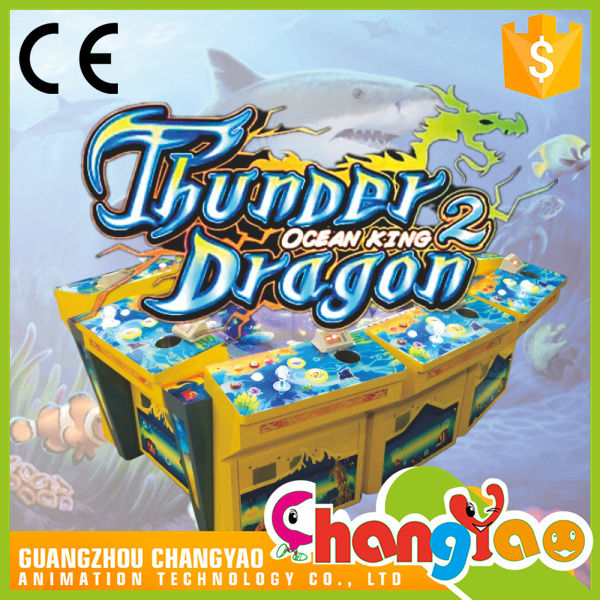What type of game does "Thunder Dragon 2 Ocean King" imply, based on the imagery and controls visible? Based on the imagery and controls visible on the arcade machine, "Thunder Dragon 2 Ocean King" implies a multiplayer interactive shooting or fishing game. The presence of joysticks and individual playing stations suggests that multiple players can control their own actions within the game, likely aiming to catch or shoot aquatic creatures displayed on the central screen. The ocean-themed graphics and the name "Ocean King" combined with the depicted sea creatures and the shark suggest a competitive nature, possibly involving hunting or capturing fish or battling sea monsters for points or rewards. 